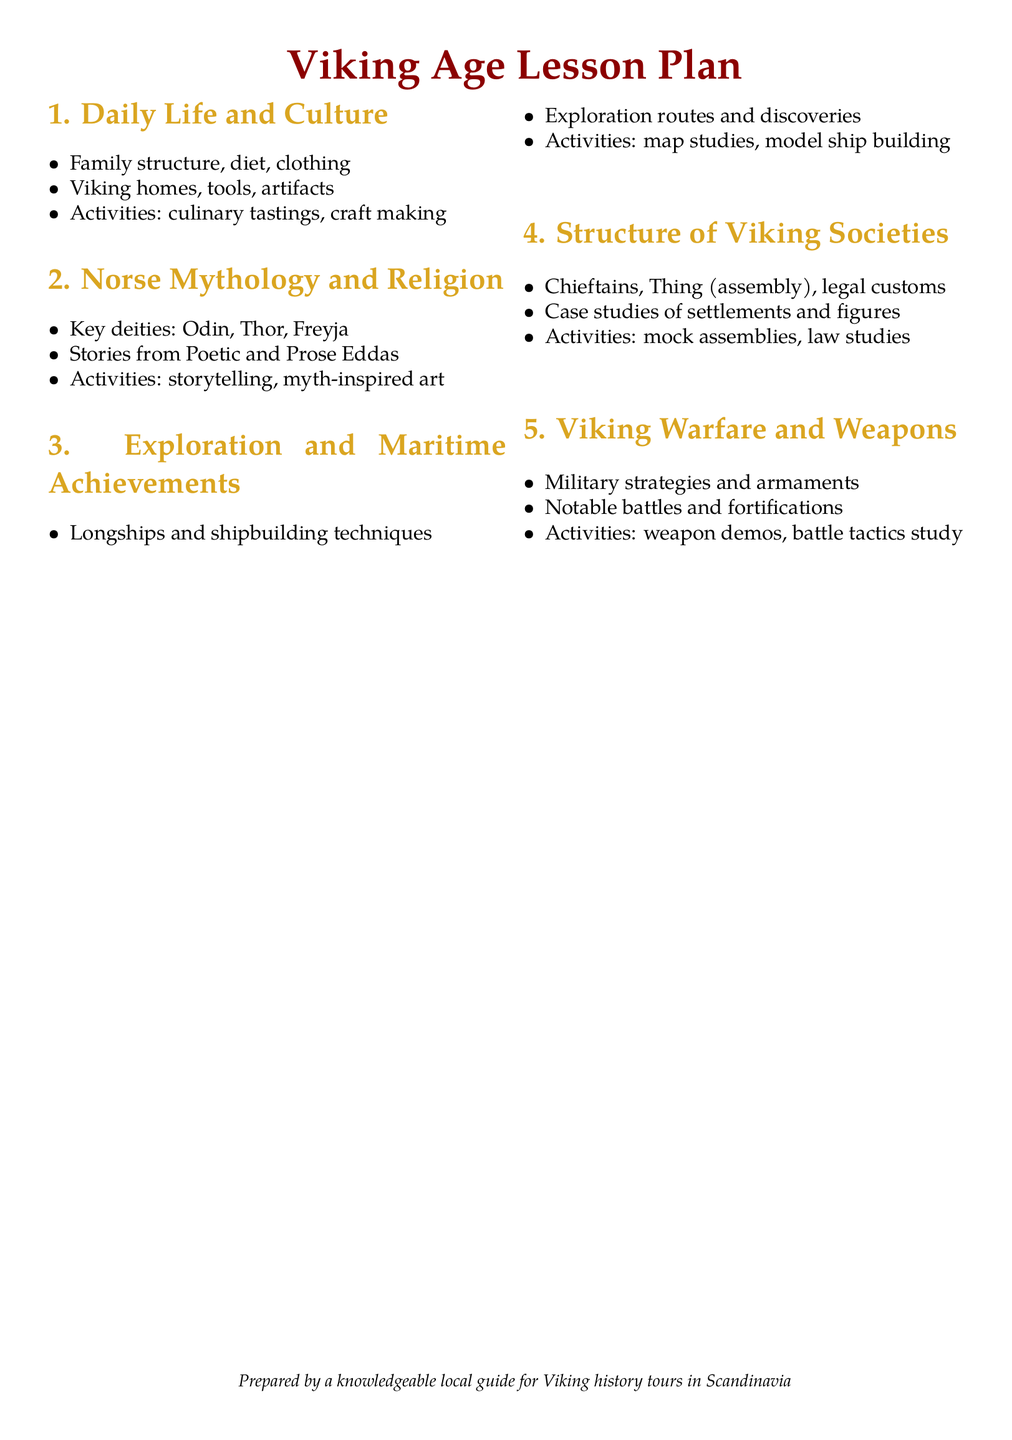What are the key deities mentioned? The key deities are listed in the section about Norse Mythology and Religion.
Answer: Odin, Thor, Freyja What activities are included in the Daily Life and Culture section? The activities listed under Daily Life and Culture describe hands-on experiences related to Viking life.
Answer: Culinary tastings, craft making What is the focus of the Exploration and Maritime Achievements lesson? The lesson focuses on Viking seafaring capabilities and achievements.
Answer: Seafaring prowess What social structure is mentioned under Viking Societies? The structure assessed is focused on community leadership roles in Viking cultures.
Answer: Chieftains What type of activities are proposed for the Warfare and Weapons lesson? The activities involve understanding Viking military practices through interactive learning.
Answer: Weapon demos, battle tactics study 